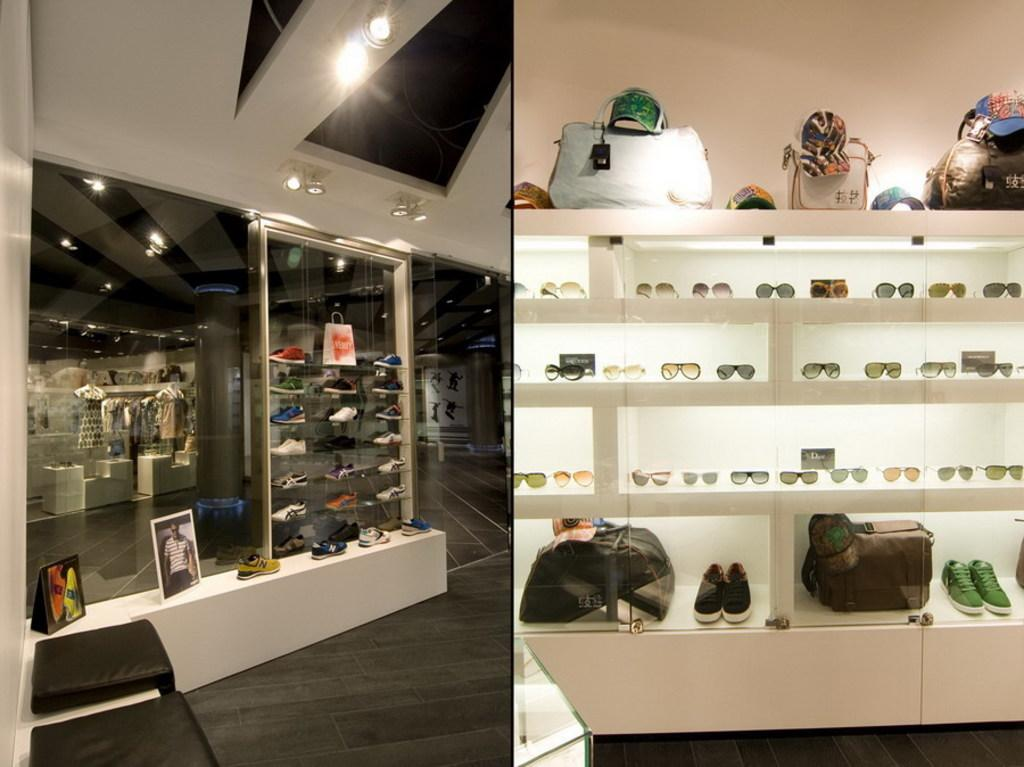What type of reflective surface is present in the image? There is a mirror in the image. What type of personal items can be seen in the image? There are bags, shoes, and spectacles in the image. How are these items arranged in the image? All these items are in racks. What type of marble is visible in the image? There is no marble present in the image. How does the person push the bags in the image? There are no people or actions of pushing in the image. 